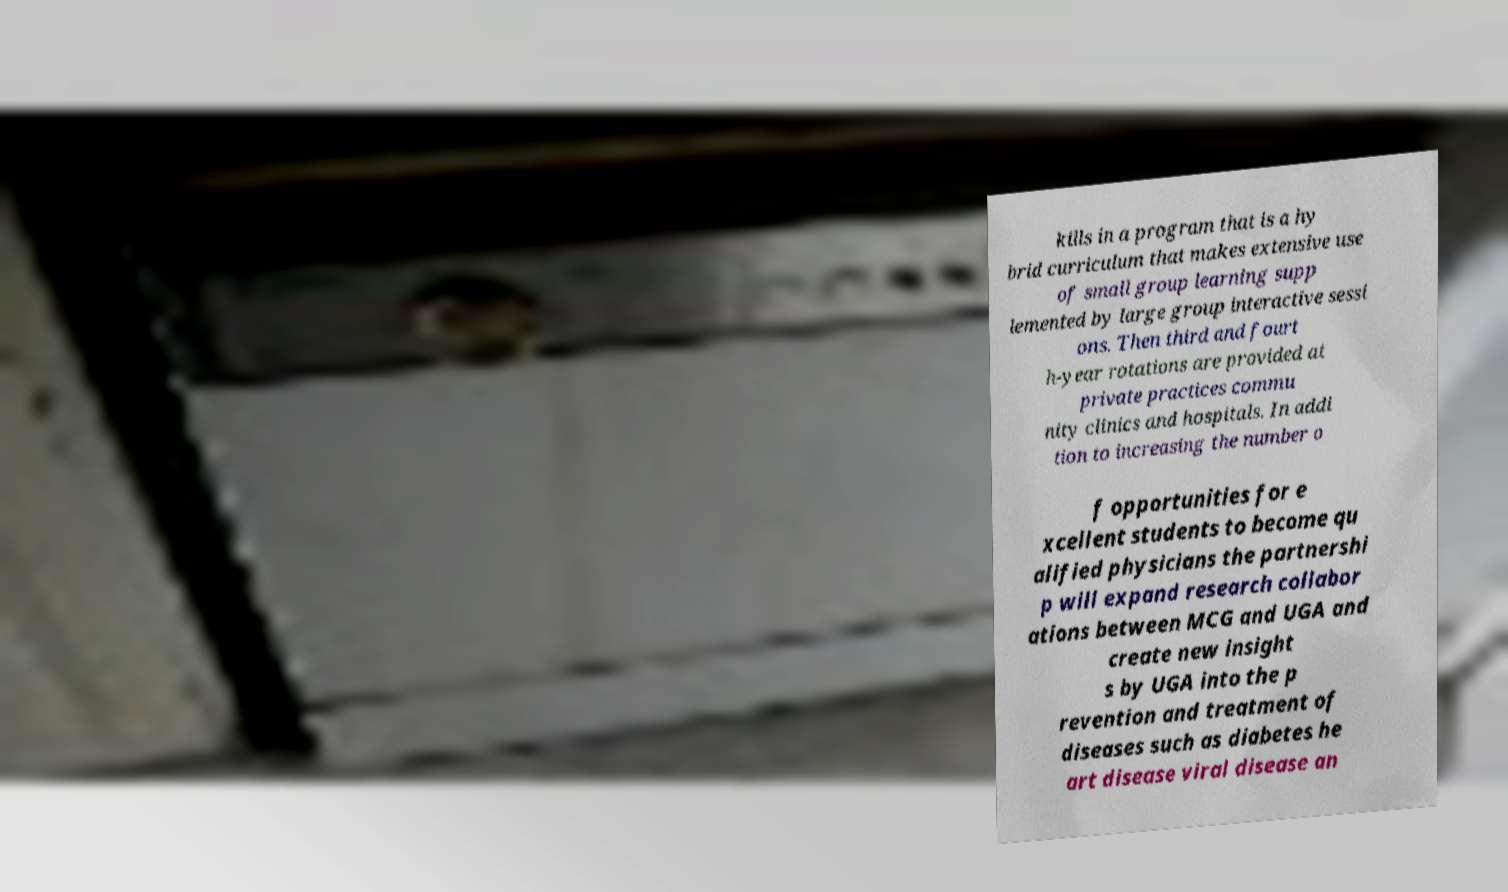Please identify and transcribe the text found in this image. kills in a program that is a hy brid curriculum that makes extensive use of small group learning supp lemented by large group interactive sessi ons. Then third and fourt h-year rotations are provided at private practices commu nity clinics and hospitals. In addi tion to increasing the number o f opportunities for e xcellent students to become qu alified physicians the partnershi p will expand research collabor ations between MCG and UGA and create new insight s by UGA into the p revention and treatment of diseases such as diabetes he art disease viral disease an 